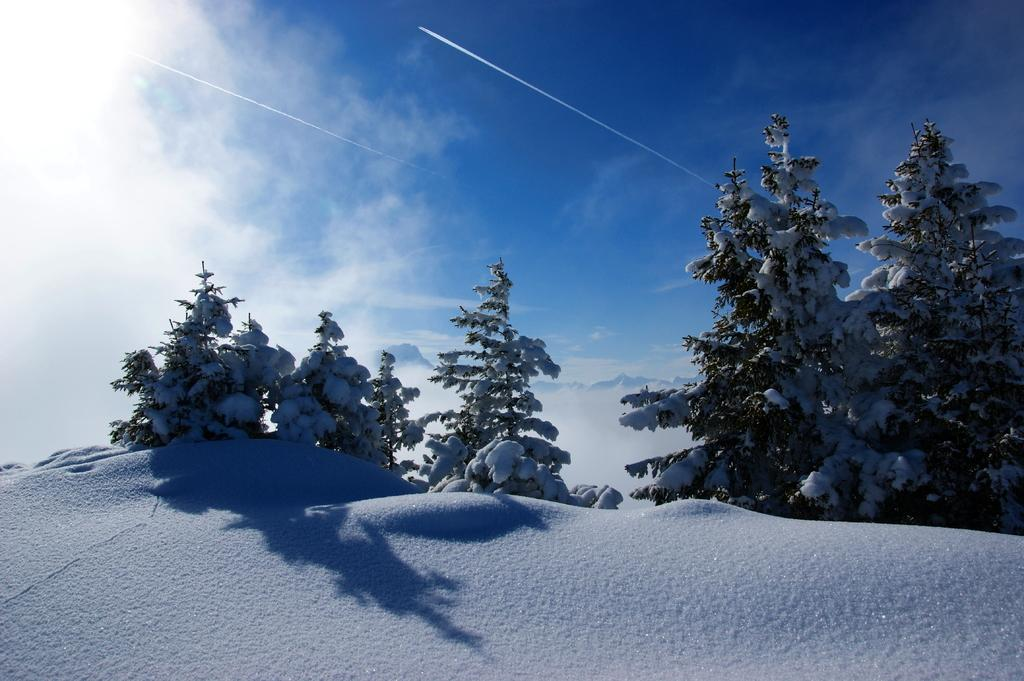What is the primary feature of the landscape in the image? There is snow in the image. What type of vegetation can be seen in the image? There are trees in the image. How does the snow affect the appearance of the trees? Snow is present on the trees in the image. What can be seen in the background of the image? The sky is visible in the background of the image. What type of ice is being turned into a page in the image? There is no ice or page present in the image; it features snow and trees. What type of experience can be gained from the image? The image itself does not provide an experience, but it may evoke feelings or memories related to snow and winter landscapes. 